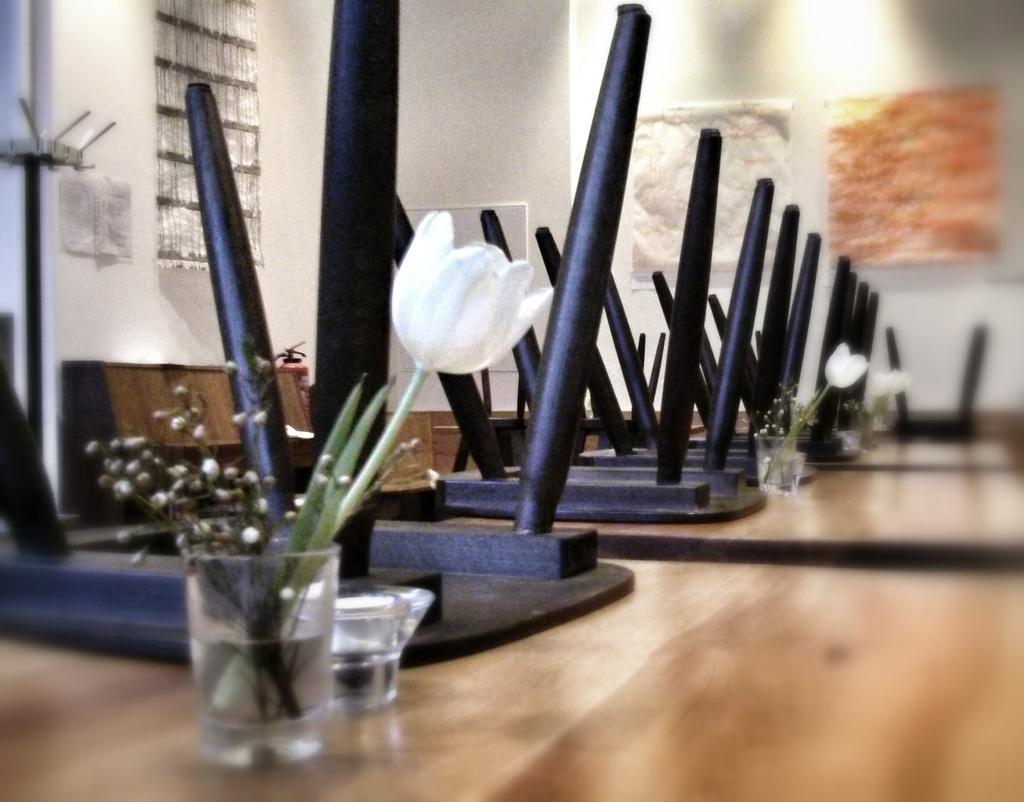How would you summarize this image in a sentence or two? There are wooden tables. On that there are glasses with flowers. Also there are chairs on the table. In the back there is a wall. 